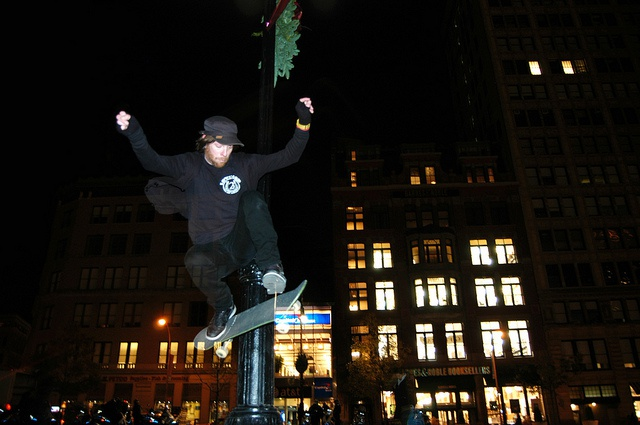Describe the objects in this image and their specific colors. I can see people in black, gray, and lightgray tones, skateboard in black, gray, ivory, and darkgray tones, backpack in black tones, and people in black and maroon tones in this image. 